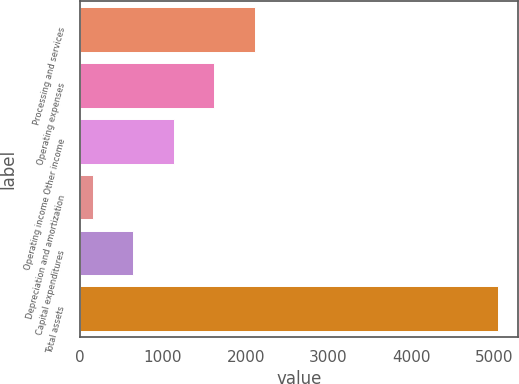Convert chart. <chart><loc_0><loc_0><loc_500><loc_500><bar_chart><fcel>Processing and services<fcel>Operating expenses<fcel>Operating income Other income<fcel>Depreciation and amortization<fcel>Capital expenditures<fcel>Total assets<nl><fcel>2110.86<fcel>1621.67<fcel>1132.48<fcel>154.1<fcel>643.29<fcel>5046<nl></chart> 